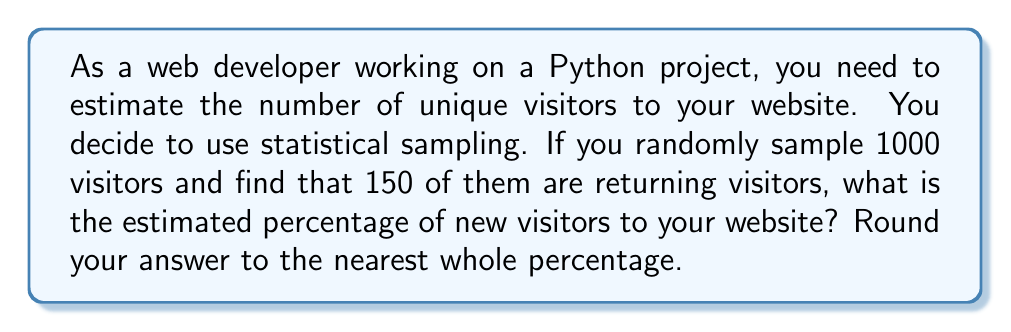Give your solution to this math problem. Let's approach this step-by-step:

1) First, we need to understand what the sample represents:
   - Total sample size: 1000 visitors
   - Number of returning visitors in the sample: 150

2) To find the number of new visitors in the sample:
   $\text{New visitors} = \text{Total visitors} - \text{Returning visitors}$
   $\text{New visitors} = 1000 - 150 = 850$

3) Now, we can calculate the percentage of new visitors:
   $$\text{Percentage of new visitors} = \frac{\text{New visitors}}{\text{Total visitors}} \times 100\%$$

4) Plugging in our numbers:
   $$\text{Percentage of new visitors} = \frac{850}{1000} \times 100\% = 0.85 \times 100\% = 85\%$$

5) The question asks to round to the nearest whole percentage, but 85% is already a whole number, so no further rounding is necessary.

This statistical sampling method provides an estimate of the percentage of new visitors to your website. In a Python implementation, you could use this percentage to estimate the number of unique visitors over a given period, assuming you know the total number of visits.
Answer: 85% 